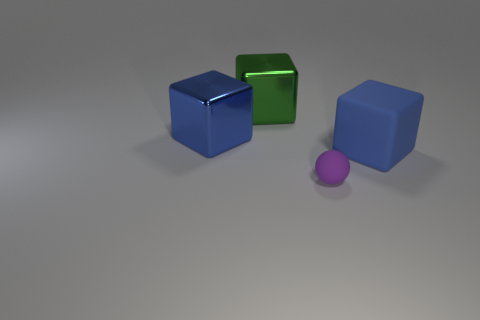Subtract all big blue blocks. How many blocks are left? 1 Subtract all blue cylinders. How many blue blocks are left? 2 Add 4 blue rubber cubes. How many objects exist? 8 Subtract all green cubes. How many cubes are left? 2 Add 3 big blue matte cubes. How many big blue matte cubes exist? 4 Subtract 0 brown cubes. How many objects are left? 4 Subtract all blocks. How many objects are left? 1 Subtract all brown cubes. Subtract all cyan cylinders. How many cubes are left? 3 Subtract all matte things. Subtract all big rubber objects. How many objects are left? 1 Add 2 green metallic objects. How many green metallic objects are left? 3 